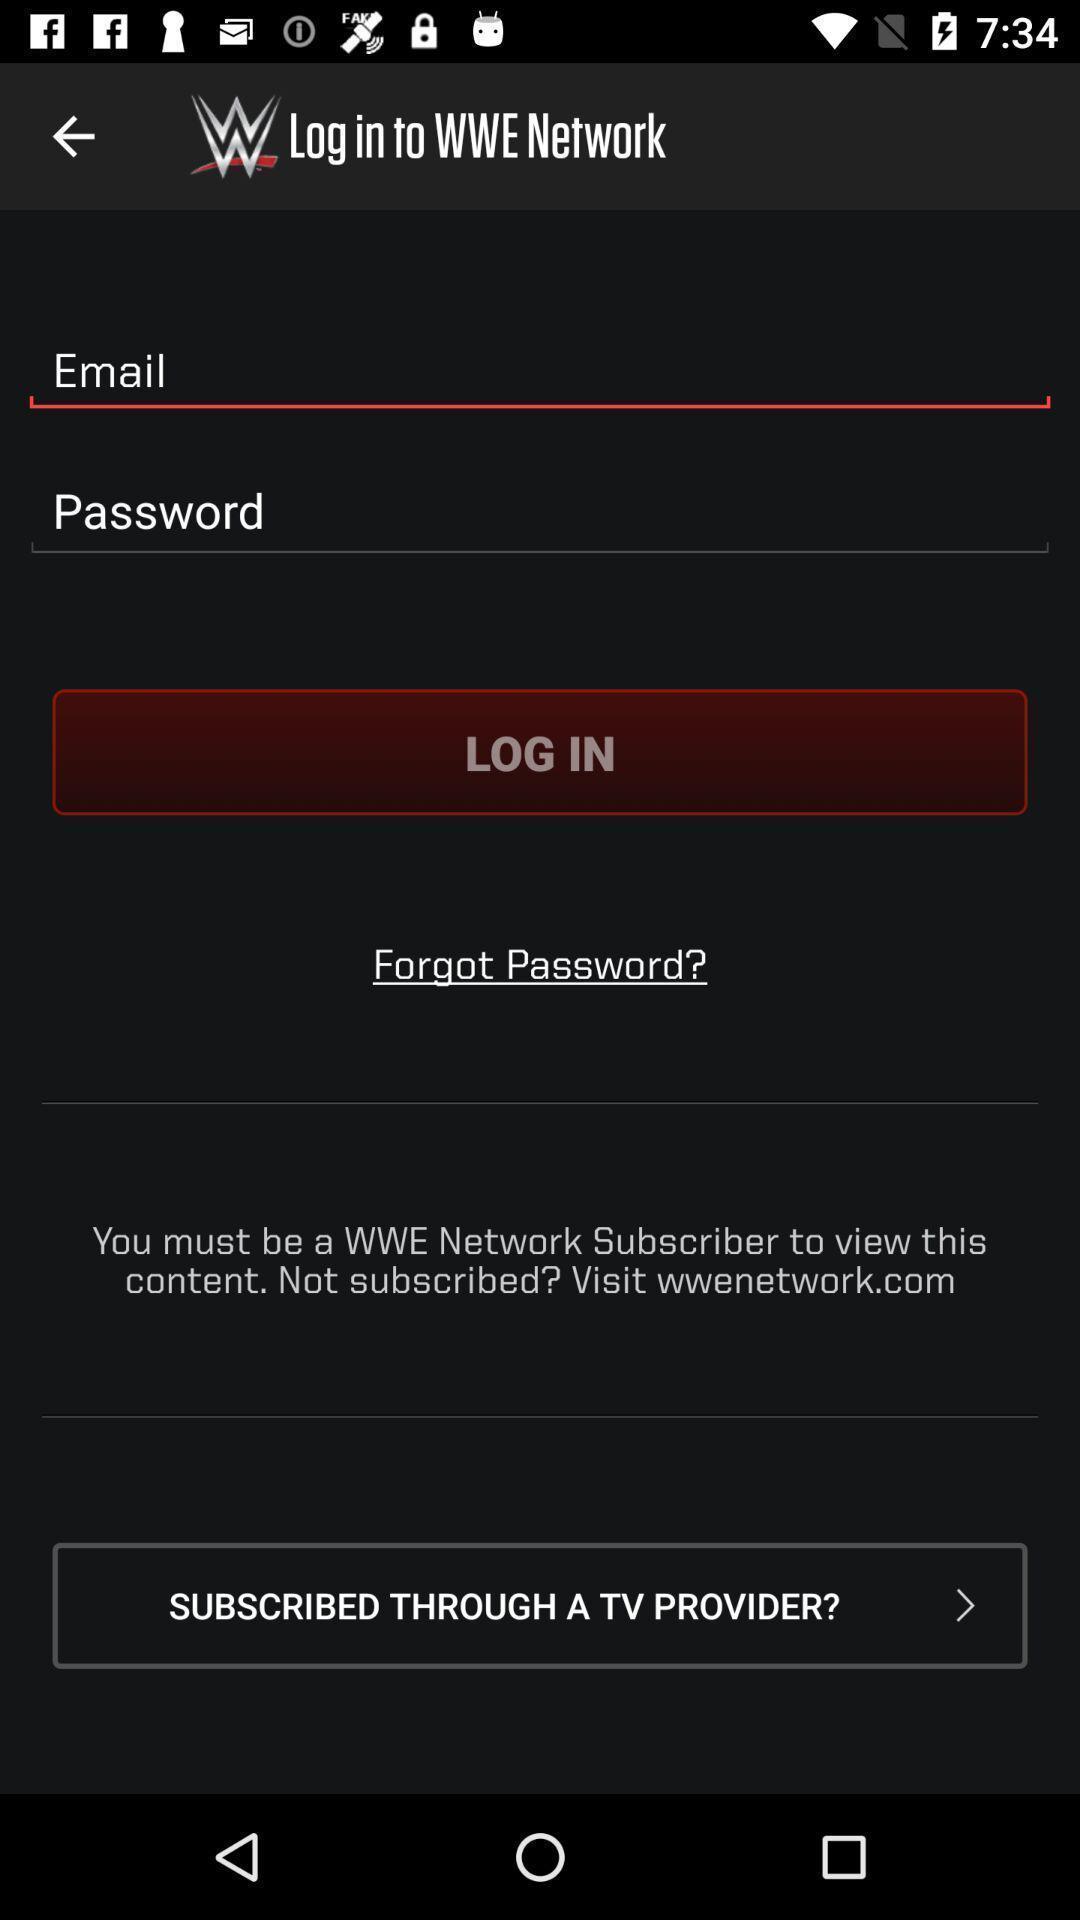Provide a textual representation of this image. Login page. 